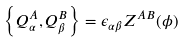Convert formula to latex. <formula><loc_0><loc_0><loc_500><loc_500>\left \{ Q _ { \alpha } ^ { A } , Q _ { \beta } ^ { B } \right \} = \epsilon _ { \alpha \beta } Z ^ { A B } ( \phi )</formula> 